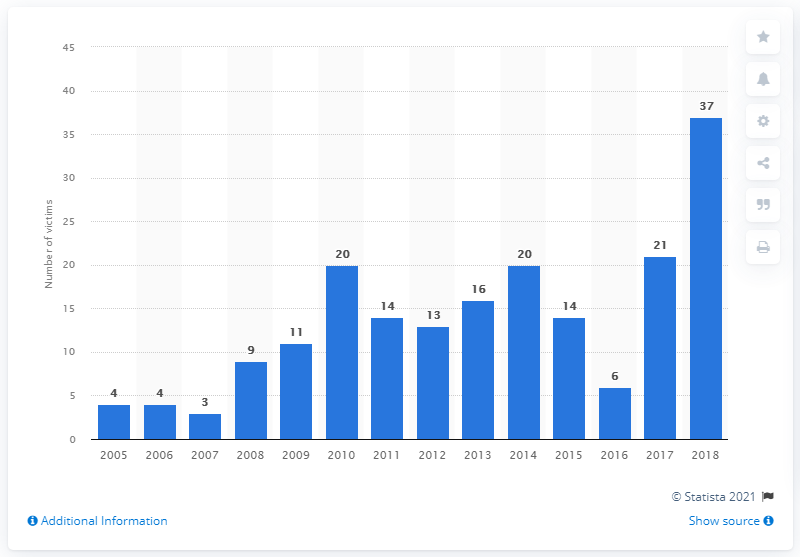How many mayors, mayoral candidates, and former mayors were murdered in Mexico in 2018?
 37 